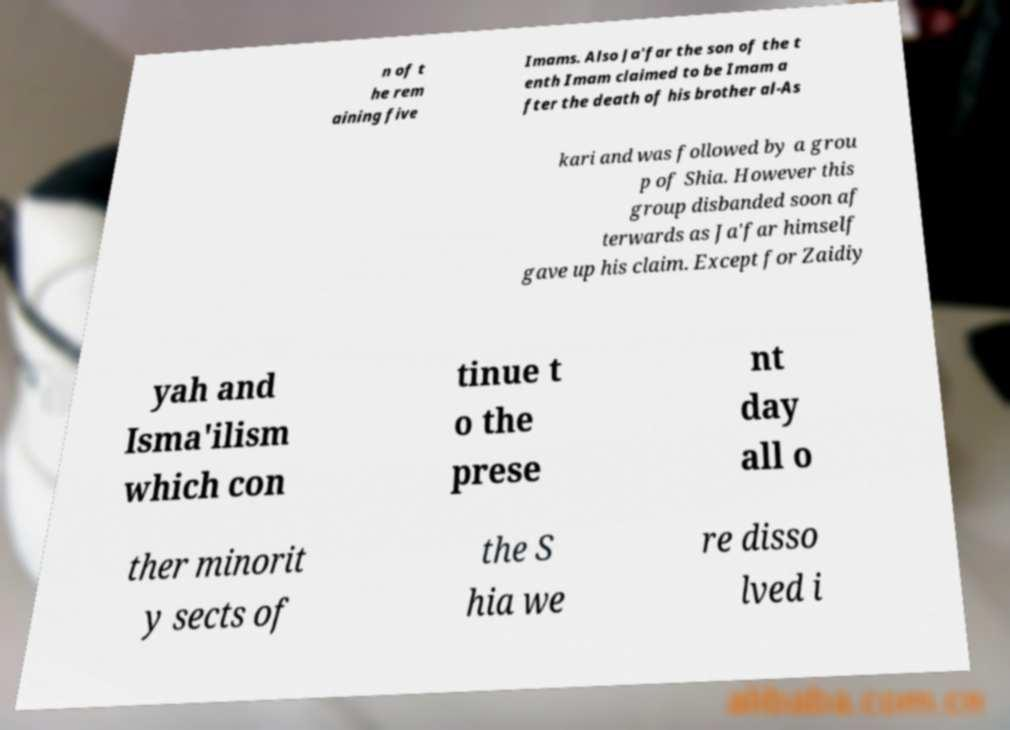Can you accurately transcribe the text from the provided image for me? n of t he rem aining five Imams. Also Ja'far the son of the t enth Imam claimed to be Imam a fter the death of his brother al-As kari and was followed by a grou p of Shia. However this group disbanded soon af terwards as Ja'far himself gave up his claim. Except for Zaidiy yah and Isma'ilism which con tinue t o the prese nt day all o ther minorit y sects of the S hia we re disso lved i 